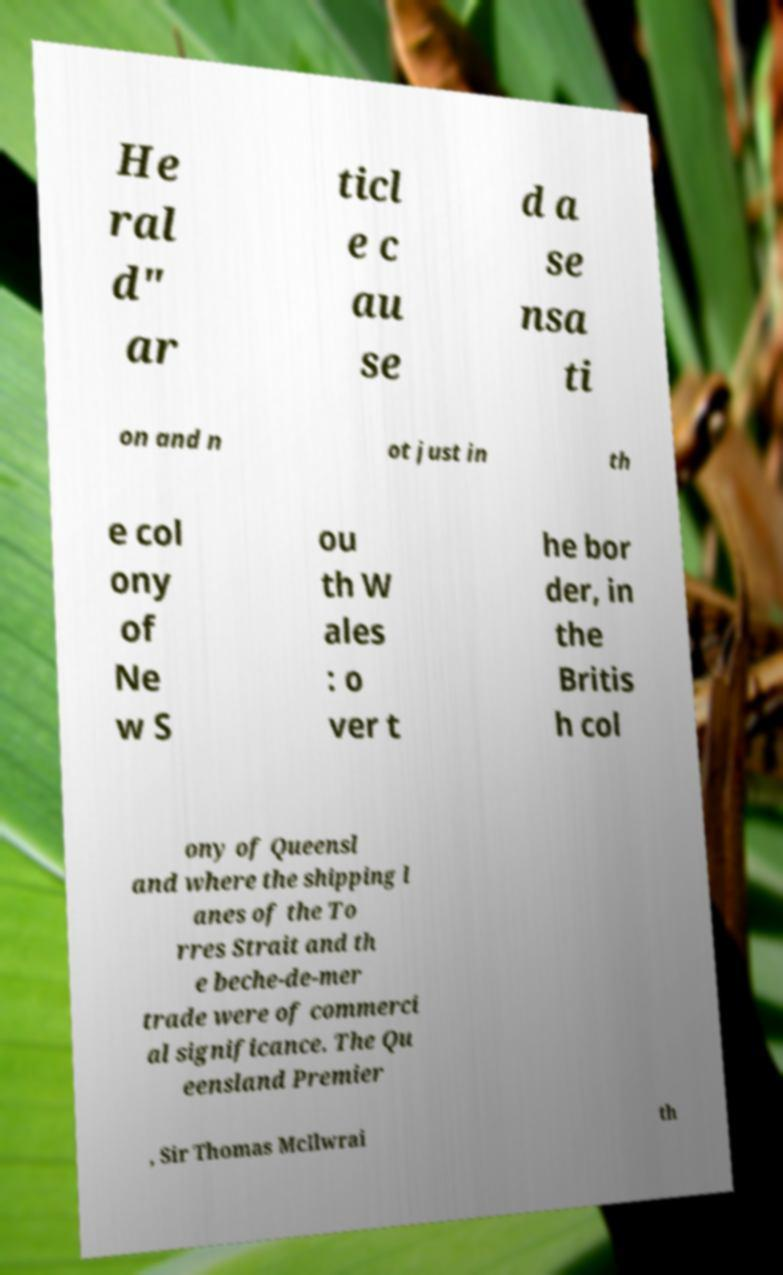There's text embedded in this image that I need extracted. Can you transcribe it verbatim? He ral d" ar ticl e c au se d a se nsa ti on and n ot just in th e col ony of Ne w S ou th W ales : o ver t he bor der, in the Britis h col ony of Queensl and where the shipping l anes of the To rres Strait and th e beche-de-mer trade were of commerci al significance. The Qu eensland Premier , Sir Thomas McIlwrai th 